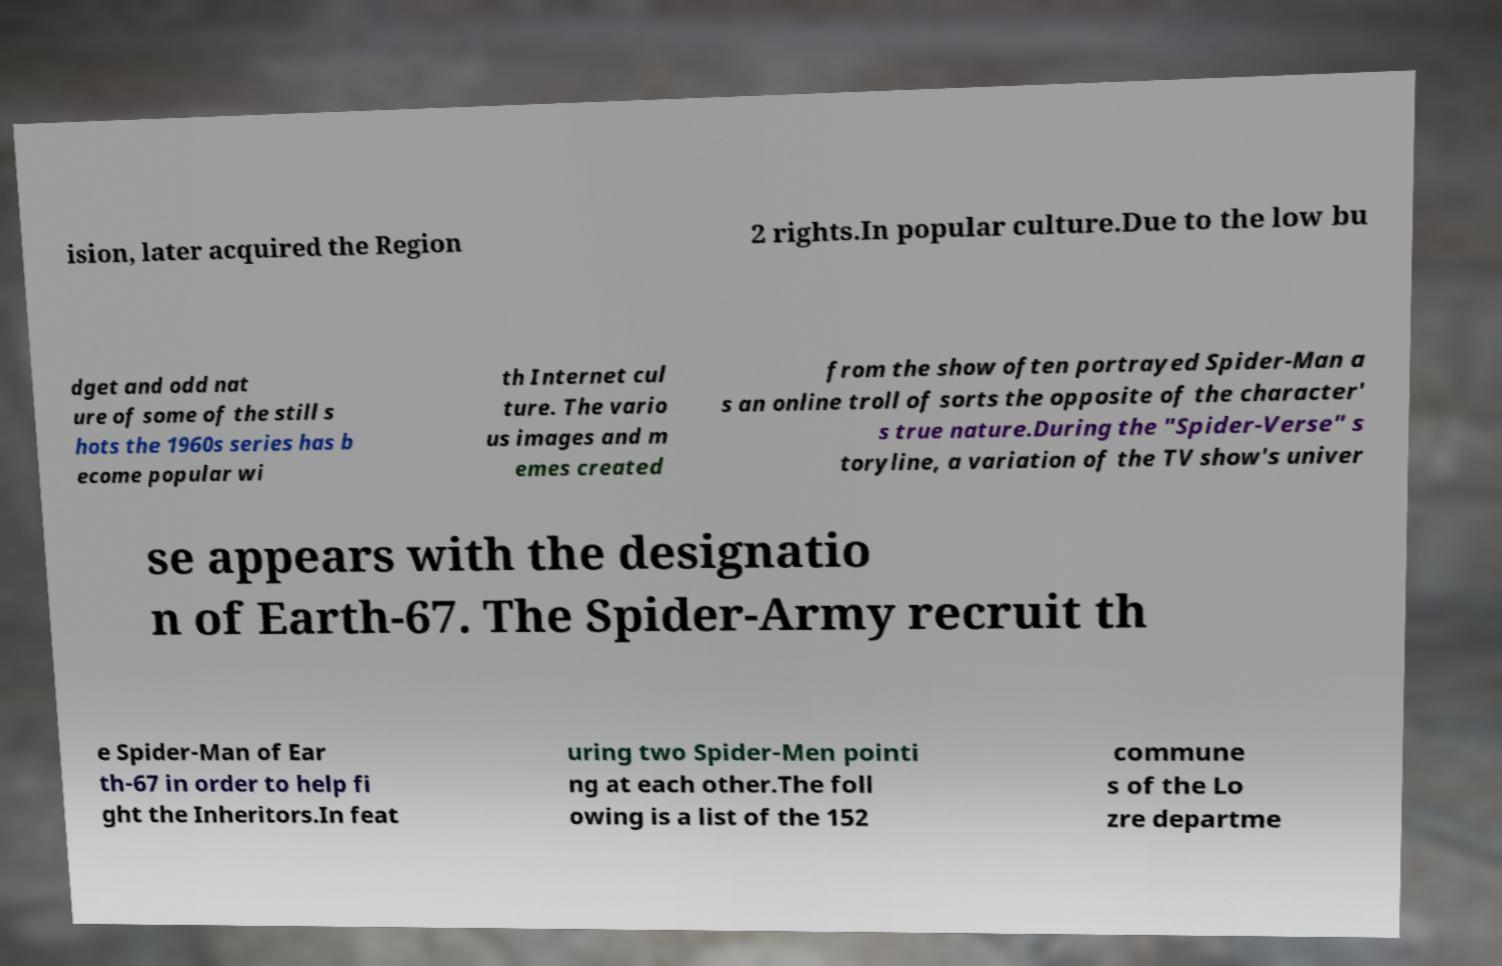Can you read and provide the text displayed in the image?This photo seems to have some interesting text. Can you extract and type it out for me? ision, later acquired the Region 2 rights.In popular culture.Due to the low bu dget and odd nat ure of some of the still s hots the 1960s series has b ecome popular wi th Internet cul ture. The vario us images and m emes created from the show often portrayed Spider-Man a s an online troll of sorts the opposite of the character' s true nature.During the "Spider-Verse" s toryline, a variation of the TV show's univer se appears with the designatio n of Earth-67. The Spider-Army recruit th e Spider-Man of Ear th-67 in order to help fi ght the Inheritors.In feat uring two Spider-Men pointi ng at each other.The foll owing is a list of the 152 commune s of the Lo zre departme 